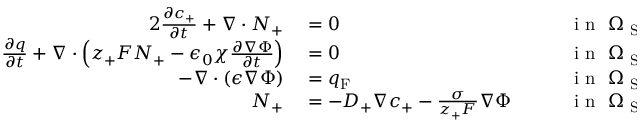<formula> <loc_0><loc_0><loc_500><loc_500>\begin{array} { r l r l } { { 2 } \frac { \partial c _ { + } } { \partial t } + \nabla \cdot N _ { + } } & = 0 } & i n \ \Omega _ { S E } , } \\ { \frac { \partial q } { \partial t } + \nabla \cdot \left ( z _ { + } F N _ { + } - \epsilon _ { 0 } \chi \frac { \partial \nabla \Phi } { \partial t } \right ) } & = 0 } & i n \ \Omega _ { S E } , } \\ { - \nabla \cdot ( \epsilon \nabla \Phi ) } & = q _ { F } } & i n \ \Omega _ { S E } , } \\ { N _ { + } } & = - D _ { + } \nabla c _ { + } - \frac { \sigma } { z _ { + } F } \nabla \Phi \quad } & i n \ \Omega _ { S E } . } \end{array}</formula> 